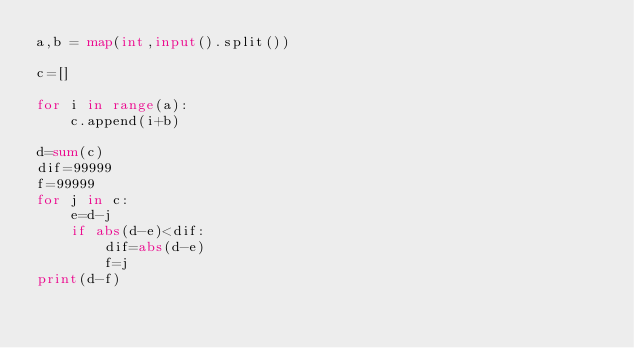<code> <loc_0><loc_0><loc_500><loc_500><_Python_>a,b = map(int,input().split())

c=[]

for i in range(a):
    c.append(i+b)

d=sum(c)
dif=99999
f=99999
for j in c:
    e=d-j
    if abs(d-e)<dif:
        dif=abs(d-e)
        f=j
print(d-f)        </code> 